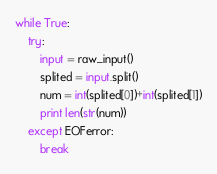<code> <loc_0><loc_0><loc_500><loc_500><_Python_>while True:
	try:
		input = raw_input()
		splited = input.split()
		num = int(splited[0])+int(splited[1])
		print len(str(num))
	except EOFerror:
		break</code> 